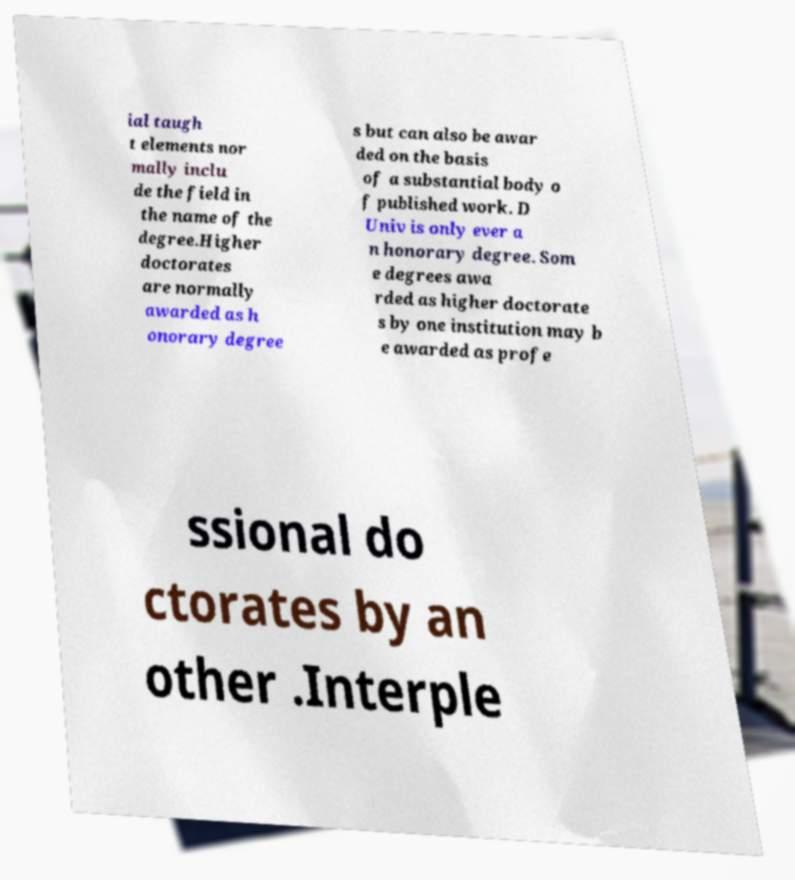Can you accurately transcribe the text from the provided image for me? ial taugh t elements nor mally inclu de the field in the name of the degree.Higher doctorates are normally awarded as h onorary degree s but can also be awar ded on the basis of a substantial body o f published work. D Univ is only ever a n honorary degree. Som e degrees awa rded as higher doctorate s by one institution may b e awarded as profe ssional do ctorates by an other .Interple 